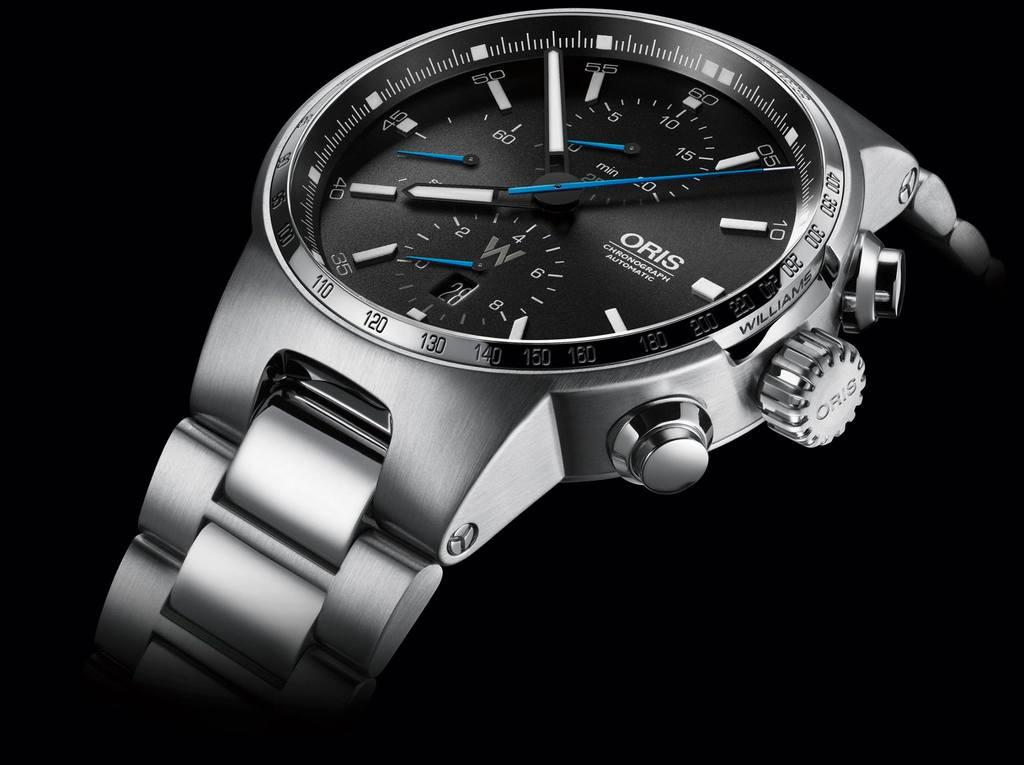<image>
Offer a succinct explanation of the picture presented. Oris Chronograph Automatic metallic men's watch with chunky metallic wrist bands and 3 buttons on side. 